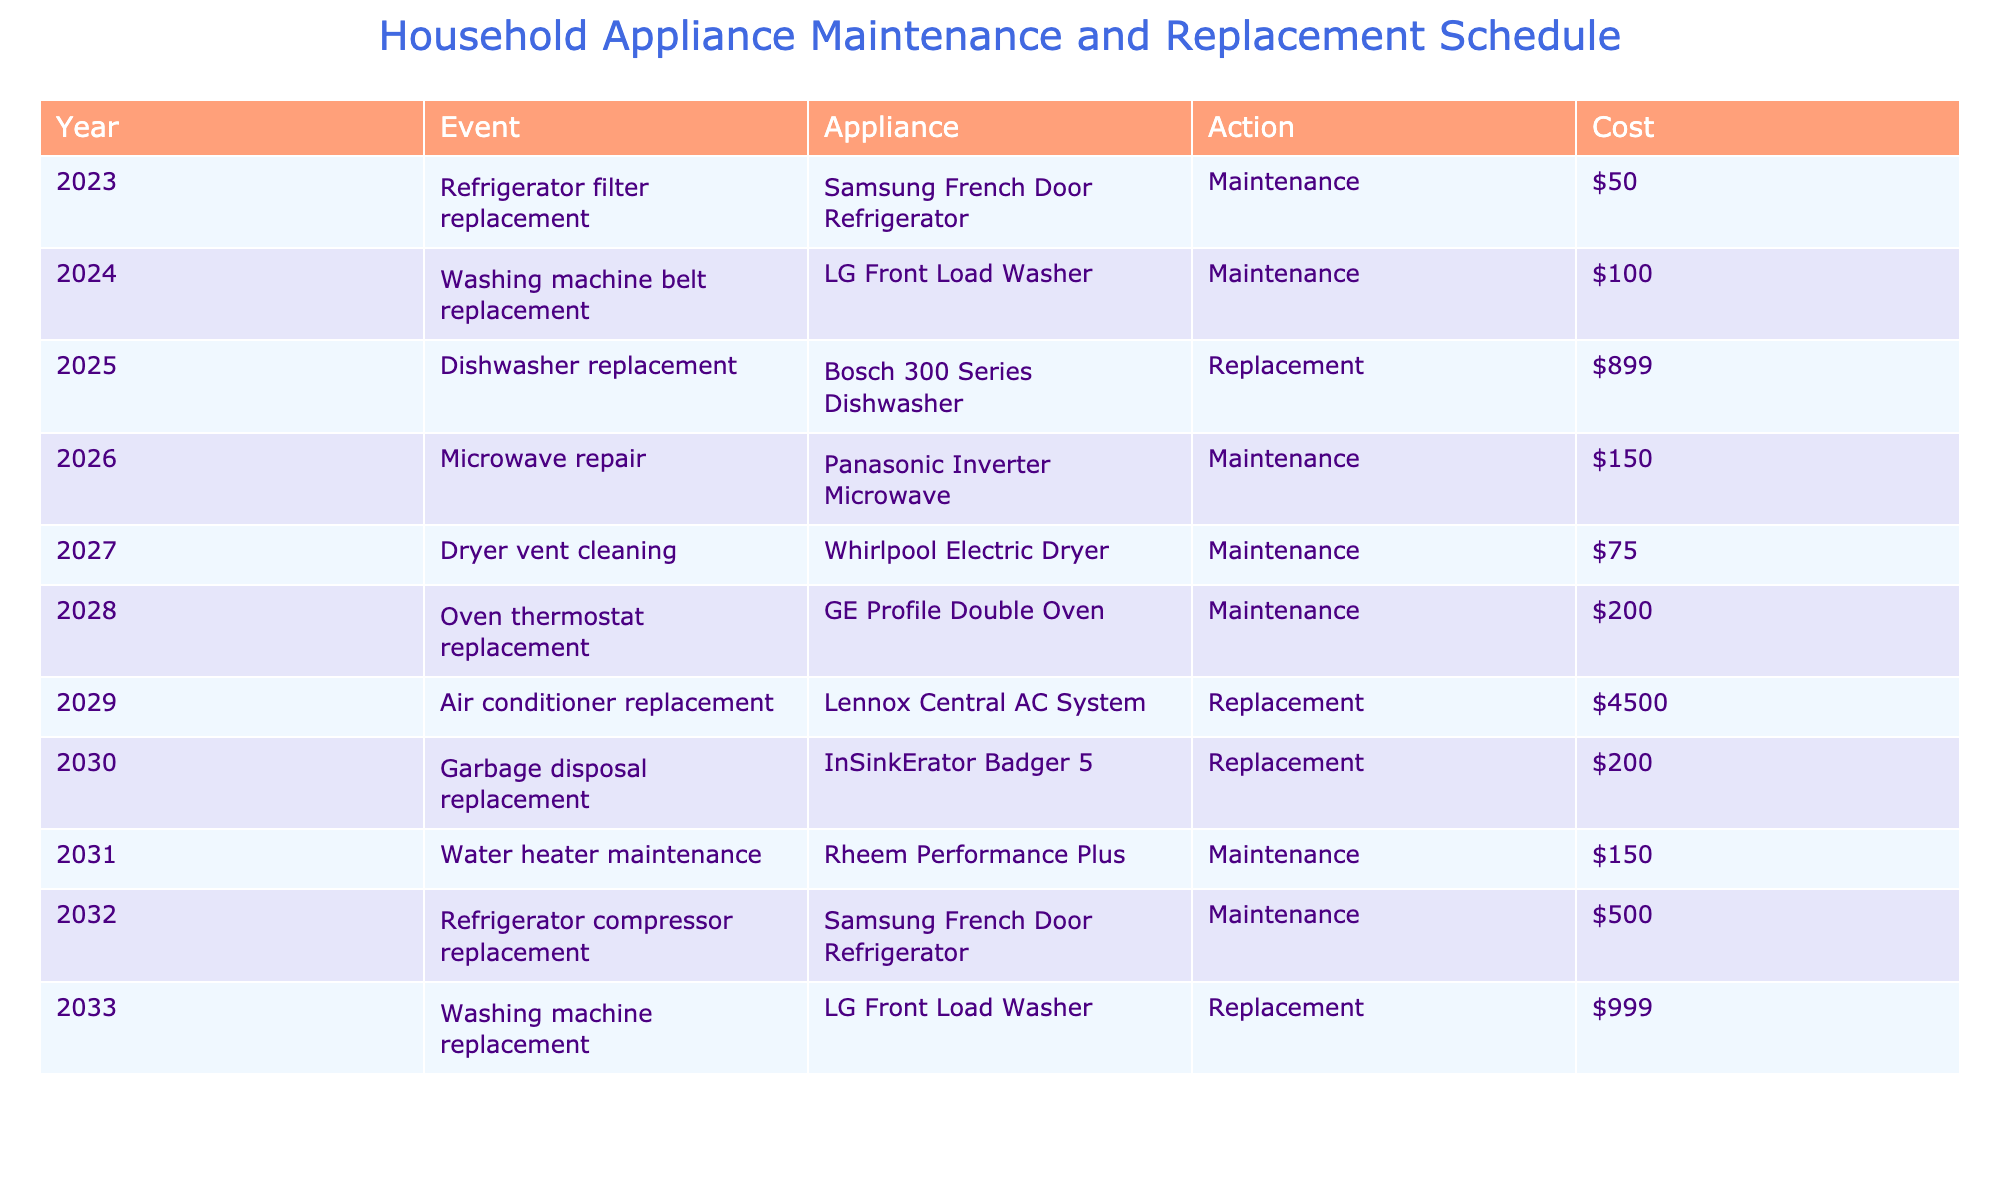What is the total cost of the dishwasher replacement? The dishwasher replacement is listed in the table for the year 2025 with a cost of $899. Therefore, the total cost for this specific event is simply the cost stated.
Answer: $899 In which year is the air conditioner replacement scheduled? Referring to the table, the air conditioner replacement is scheduled for the year 2029 as shown in the corresponding event row.
Answer: 2029 How many maintenance actions are planned before 2030? To determine the number of maintenance actions before the year 2030, we look at the table for events listed before that year. Counting the maintenance actions prior to 2030: 2023, 2024, 2026, 2027, 2028, and 2031, we find there are 6 maintenance actions.
Answer: 6 What is the average cost of all the replacements listed? The replacement costs are: $899 for the dishwasher, $4500 for the air conditioner, $200 for the garbage disposal, and $999 for the washing machine. Summing these gives 899 + 4500 + 200 + 999 = $5798. Since there are 4 replacement events, the average cost is $5798 / 4 = $1449.50.
Answer: $1449.50 Is the refrigerator filter replacement the least expensive maintenance action? In examining the maintenance actions, we see that the refrigerator filter replacement is $50, while the other maintenance actions listed are $100, $150, $75, $200, and $150. The lowest cost of these maintenance actions is indeed $50, confirming that it is the least expensive.
Answer: Yes Which appliance has the most expensive maintenance action scheduled in this table? The maintenance actions include costs of $50, $100, $150, $75, $200, and $150. The highest among these is the oven thermostat replacement, costing $200. Thus, while this is a maintenance action for an oven, it is the most expensive maintenance action in terms of cost from those listed.
Answer: Oven thermostat replacement ($200) 